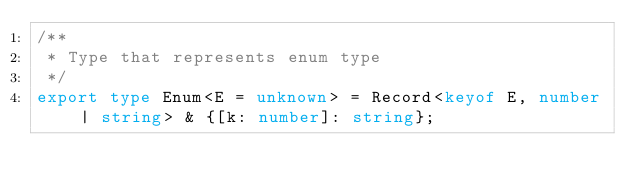<code> <loc_0><loc_0><loc_500><loc_500><_TypeScript_>/**
 * Type that represents enum type
 */
export type Enum<E = unknown> = Record<keyof E, number | string> & {[k: number]: string};
</code> 